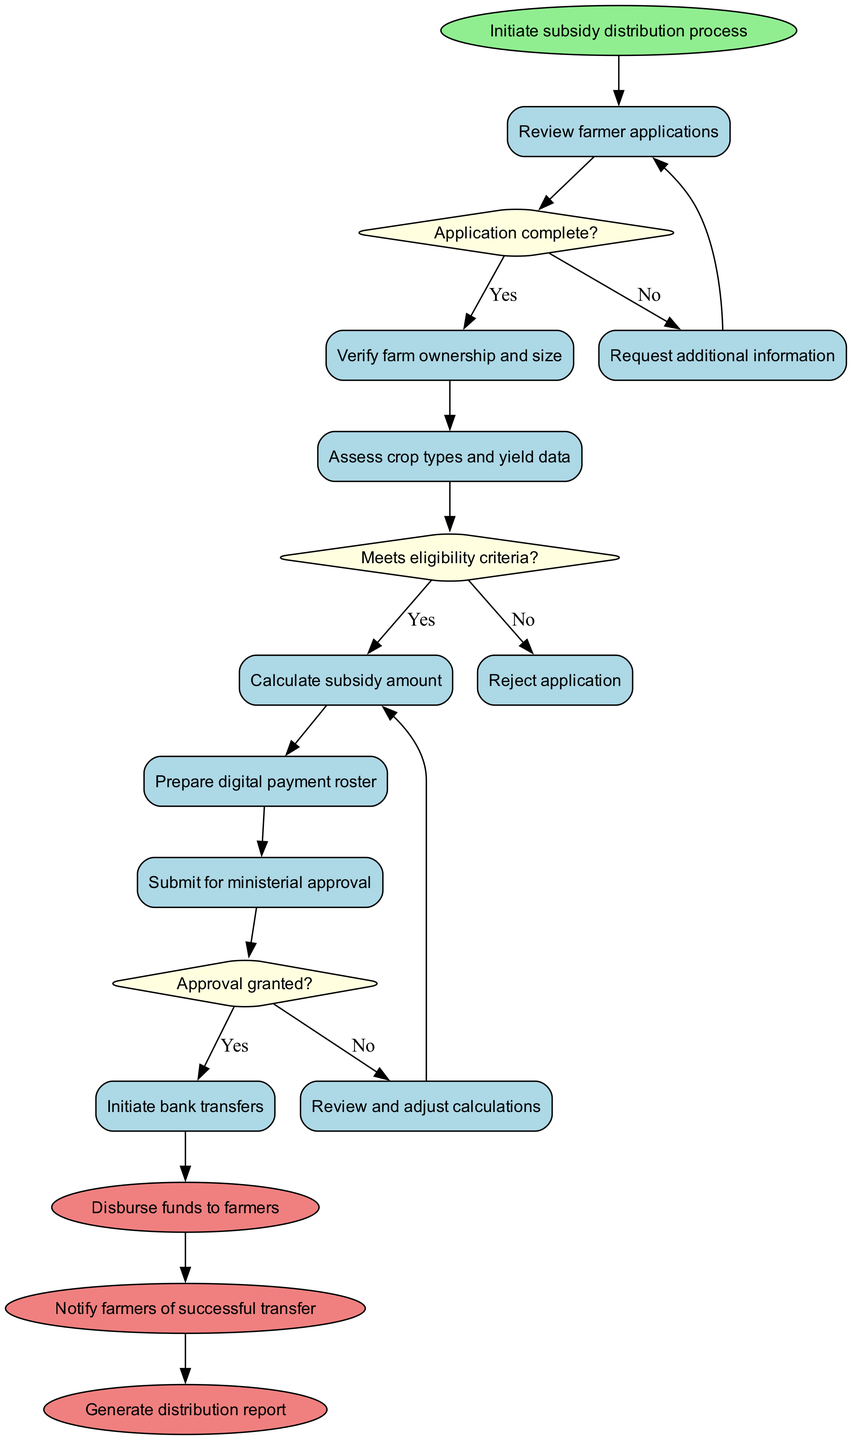What is the starting activity in the subsidy distribution process? The diagram indicates that the process begins with the activity labeled "Initiate subsidy distribution process." This is clearly shown as the first node that emerges directly from the start node.
Answer: Initiate subsidy distribution process How many activities are there in total? In the diagram, there are six defined activities listed. They are: "Review farmer applications," "Verify farm ownership and size," "Assess crop types and yield data," "Calculate subsidy amount," "Prepare digital payment roster," and "Submit for ministerial approval."
Answer: 6 What decision is made after reviewing farmer applications? The decision made after reviewing applications is whether the "Application complete?" Based on the flow, this is the first decision point after the starting activity.
Answer: Application complete? What happens if the application does not meet eligibility criteria? If the application does not meet the eligibility criteria, the process flows to the action "Reject application" as indicated in the decision labeled "Meets eligibility criteria?" which routes "No" to this specific outcome.
Answer: Reject application What is the final action taken after successful bank transfers? The final action after successfully initiating bank transfers is to "Notify farmers of successful transfer," according to the diagram's flow which connects the bank transfers to this end action directly.
Answer: Notify farmers of successful transfer If the approval is not granted, what does the process do next? If the approval is not granted, the process leads to the action labeled "Review and adjust calculations." This is directly linked to the decision node "Approval granted?" showing the flow for a "No" response.
Answer: Review and adjust calculations Which activity is directly linked to verifying farm ownership and size? The activity "Assess crop types and yield data" is directly linked to verifying farm ownership and size, as this comes after the verification step in the flow of actions depicted in the diagram.
Answer: Assess crop types and yield data What is the relationship between "Prepare digital payment roster" and "Submit for ministerial approval"? "Prepare digital payment roster" directly precedes "Submit for ministerial approval," illustrating a sequential relationship in the flow of activities as shown in the diagram.
Answer: Sequential relationship 